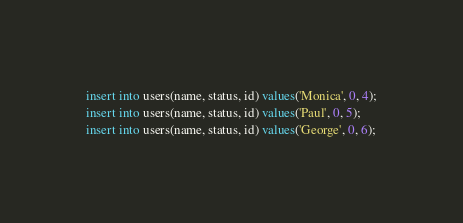<code> <loc_0><loc_0><loc_500><loc_500><_SQL_>insert into users(name, status, id) values('Monica', 0, 4);
insert into users(name, status, id) values('Paul', 0, 5);
insert into users(name, status, id) values('George', 0, 6);</code> 